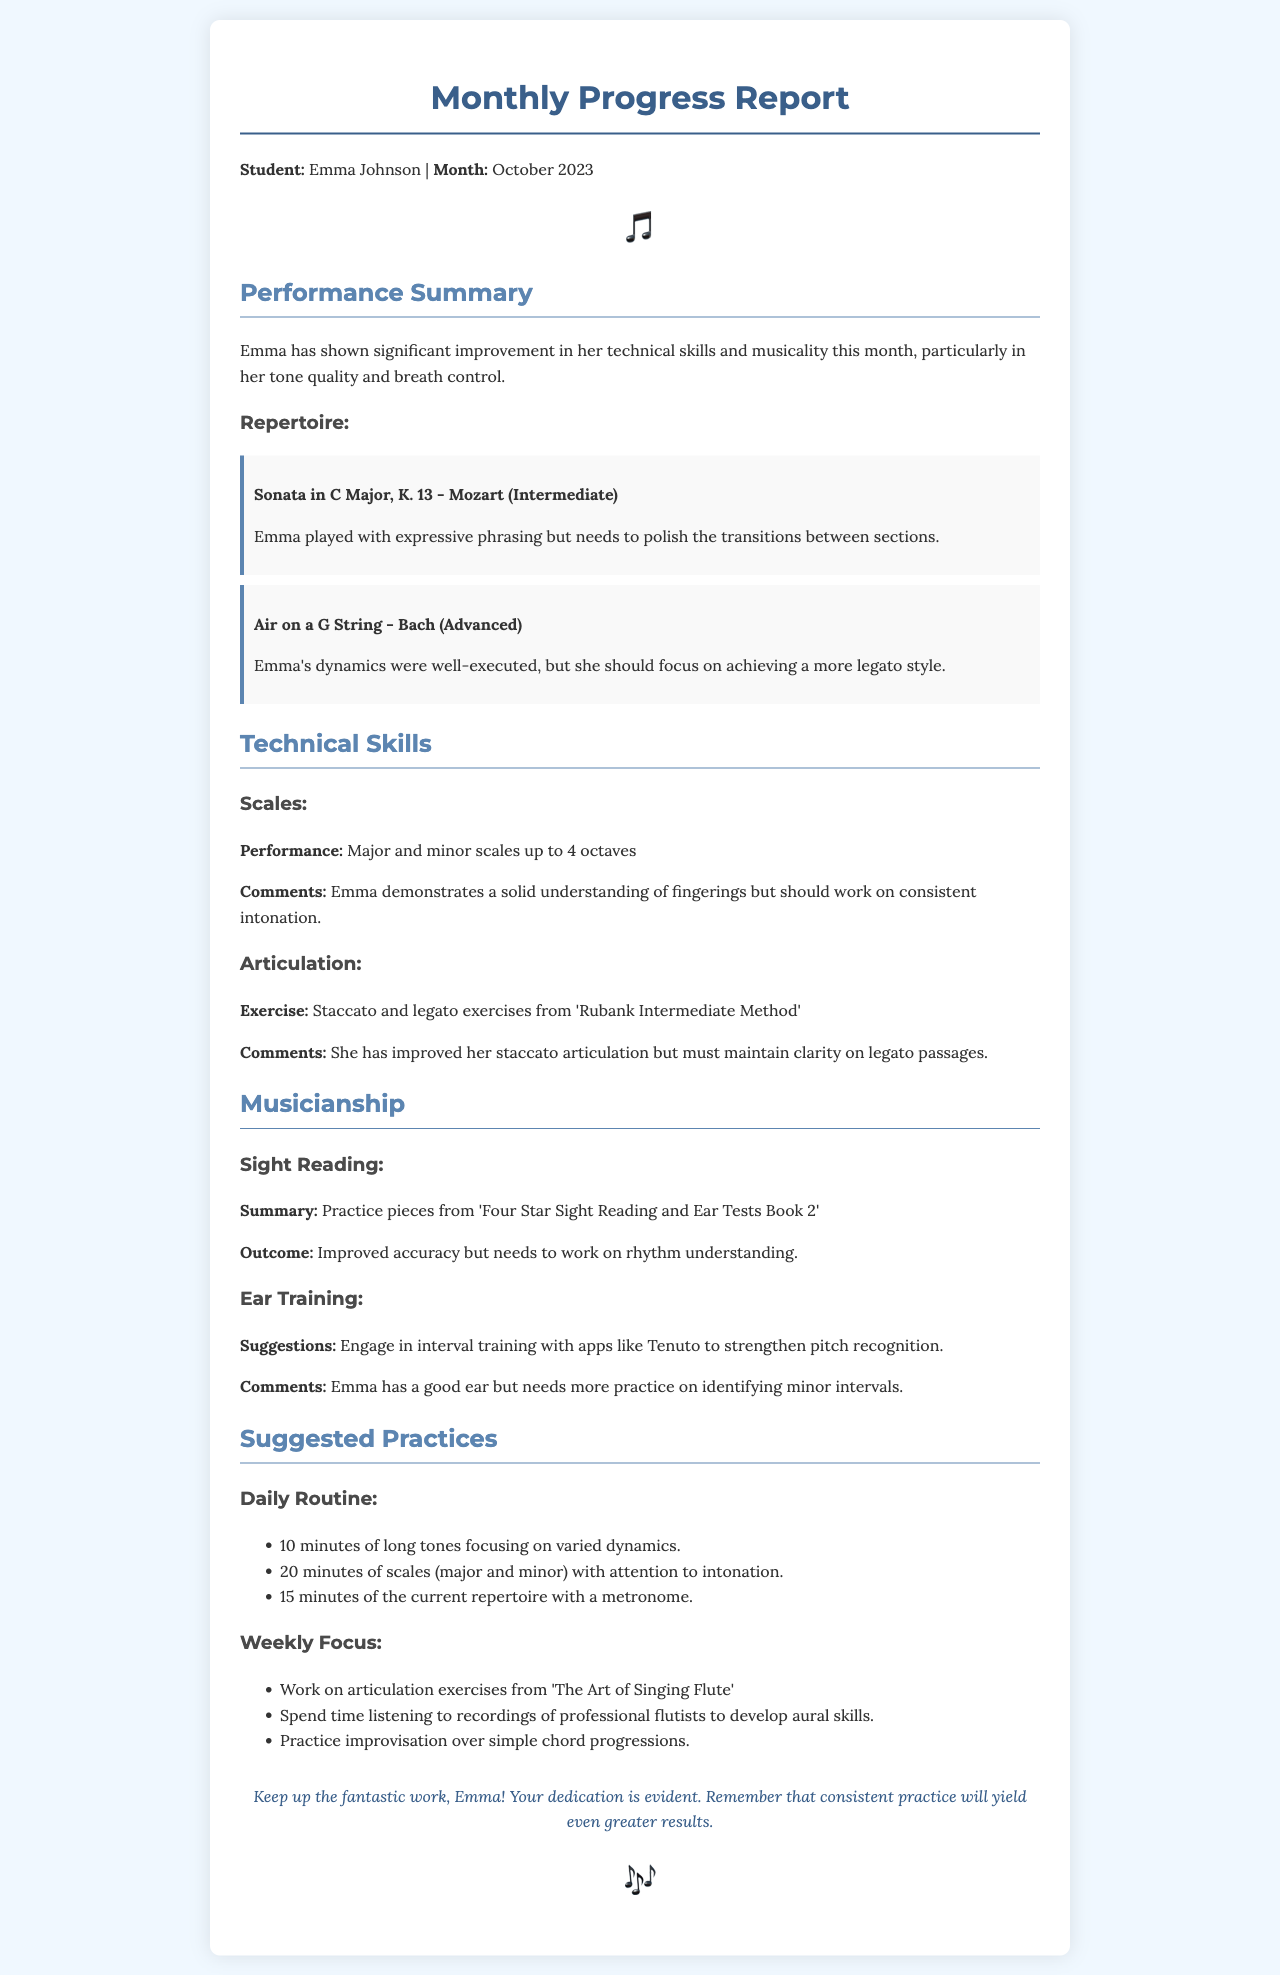What is the student's name? The document specifies the student's name as Emma Johnson.
Answer: Emma Johnson What month is this report for? The report mentions the month as October 2023.
Answer: October 2023 What is one of Emma's repertoire pieces? The document lists "Sonata in C Major, K. 13 - Mozart" as one of Emma's pieces.
Answer: Sonata in C Major, K. 13 - Mozart How many octaves can Emma play scales? The report states that Emma plays scales up to 4 octaves.
Answer: 4 octaves What is suggested for daily practice of long tones? The document recommends 10 minutes focusing on varied dynamics for long tones.
Answer: 10 minutes of long tones focusing on varied dynamics What area does Emma need to improve in her sight reading? The document indicates that Emma needs to work on rhythm understanding in her sight reading.
Answer: Rhythm understanding Which exercise improved Emma's staccato articulation? The document mentions exercises from 'Rubank Intermediate Method' as helping her staccato articulation.
Answer: Staccato and legato exercises from 'Rubank Intermediate Method' What is a suggested app for ear training? The report suggests using the app Tenuto for ear training.
Answer: Tenuto What is the encouragement message for Emma? The document includes a message encouraging Emma to keep up the fantastic work and highlighting her dedication.
Answer: Keep up the fantastic work, Emma! 